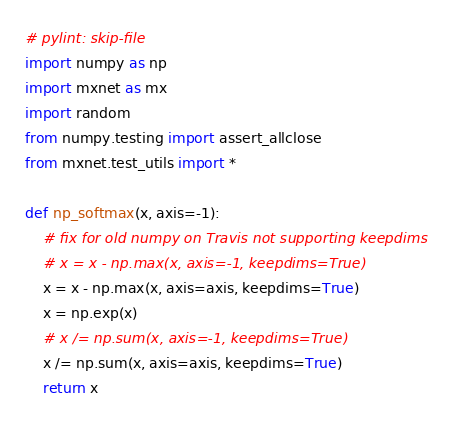Convert code to text. <code><loc_0><loc_0><loc_500><loc_500><_Python_># pylint: skip-file
import numpy as np
import mxnet as mx
import random
from numpy.testing import assert_allclose
from mxnet.test_utils import *

def np_softmax(x, axis=-1):
    # fix for old numpy on Travis not supporting keepdims
    # x = x - np.max(x, axis=-1, keepdims=True)
    x = x - np.max(x, axis=axis, keepdims=True)
    x = np.exp(x)
    # x /= np.sum(x, axis=-1, keepdims=True)
    x /= np.sum(x, axis=axis, keepdims=True)
    return x

</code> 